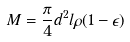Convert formula to latex. <formula><loc_0><loc_0><loc_500><loc_500>M = \frac { \pi } { 4 } d ^ { 2 } l \rho ( 1 - \epsilon )</formula> 